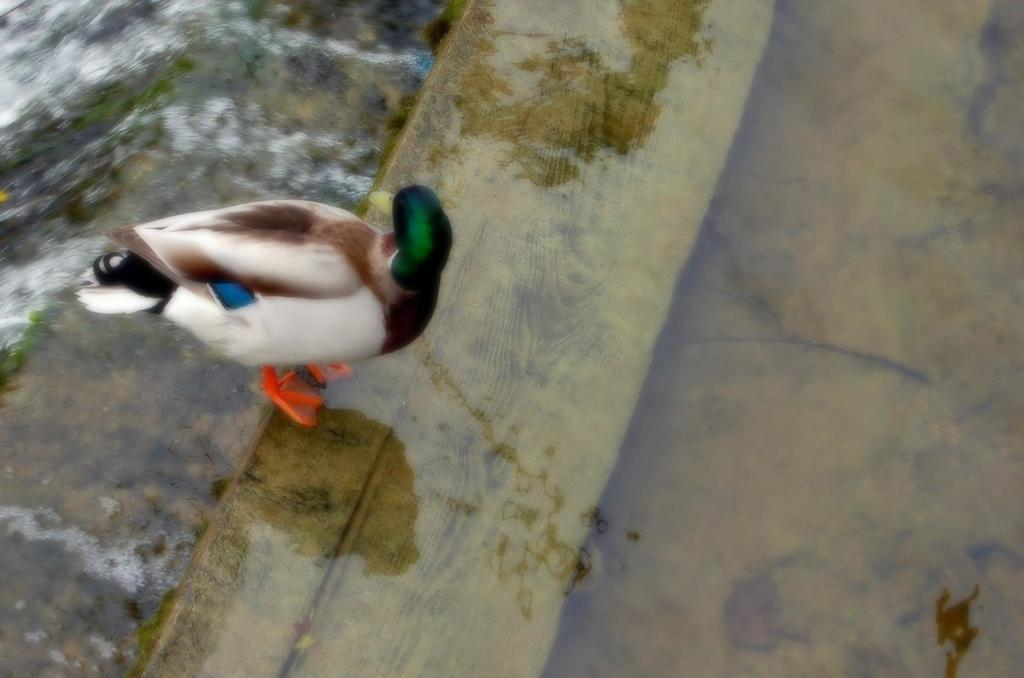What type of animal can be seen in the image? There is a white color bird in the image. Where is the bird located in the image? The bird is standing on the ground. What can be seen on the ground in the image? There is water visible on the ground. What type of jewel is the bird holding in its beak in the image? There is no jewel present in the image; the bird is standing on the ground with water visible nearby. 